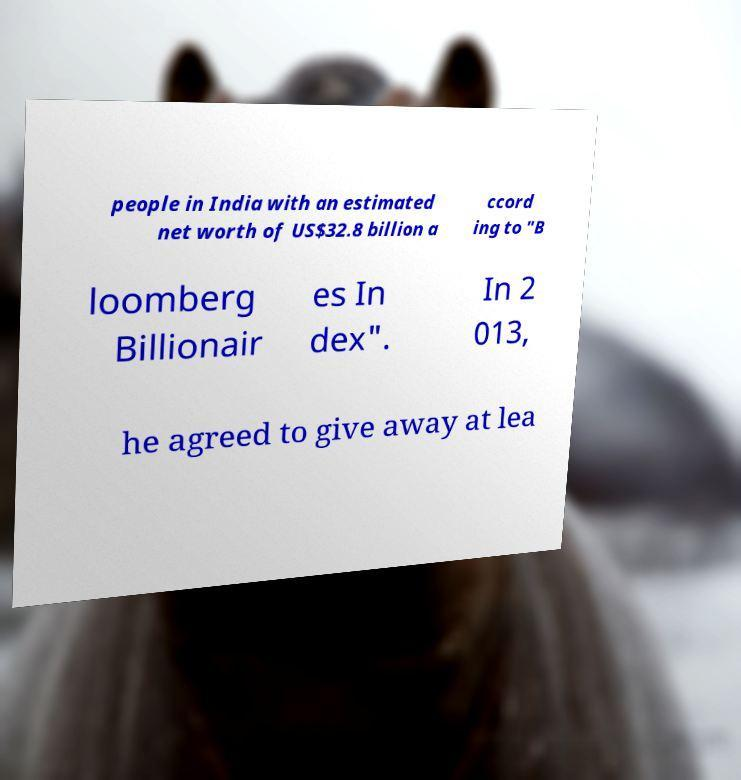For documentation purposes, I need the text within this image transcribed. Could you provide that? people in India with an estimated net worth of US$32.8 billion a ccord ing to "B loomberg Billionair es In dex". In 2 013, he agreed to give away at lea 